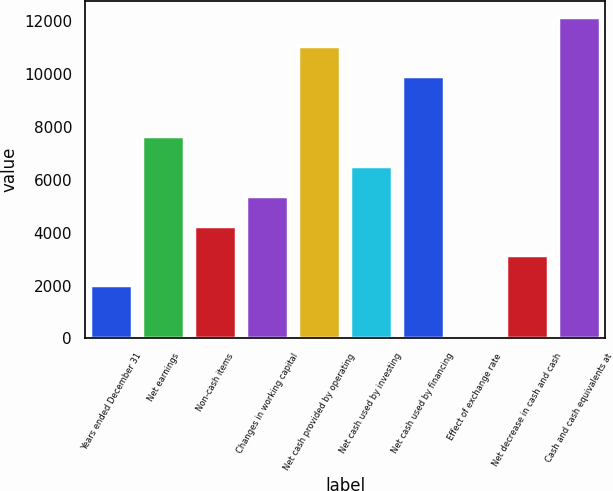<chart> <loc_0><loc_0><loc_500><loc_500><bar_chart><fcel>Years ended December 31<fcel>Net earnings<fcel>Non-cash items<fcel>Changes in working capital<fcel>Net cash provided by operating<fcel>Net cash used by investing<fcel>Net cash used by financing<fcel>Effect of exchange rate<fcel>Net decrease in cash and cash<fcel>Cash and cash equivalents at<nl><fcel>2016<fcel>7650.5<fcel>4269.8<fcel>5396.7<fcel>11054.8<fcel>6523.6<fcel>9927.9<fcel>33<fcel>3142.9<fcel>12181.7<nl></chart> 